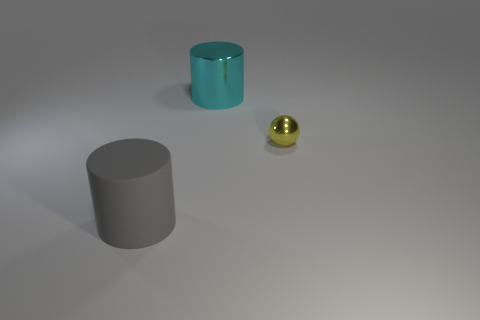Add 2 yellow metal balls. How many objects exist? 5 Subtract 1 cylinders. How many cylinders are left? 1 Subtract all purple cylinders. How many brown spheres are left? 0 Subtract all cyan cylinders. How many cylinders are left? 1 Subtract 0 cyan spheres. How many objects are left? 3 Subtract all balls. How many objects are left? 2 Subtract all red balls. Subtract all red cubes. How many balls are left? 1 Subtract all cyan objects. Subtract all large things. How many objects are left? 0 Add 2 large cyan metallic cylinders. How many large cyan metallic cylinders are left? 3 Add 3 brown rubber things. How many brown rubber things exist? 3 